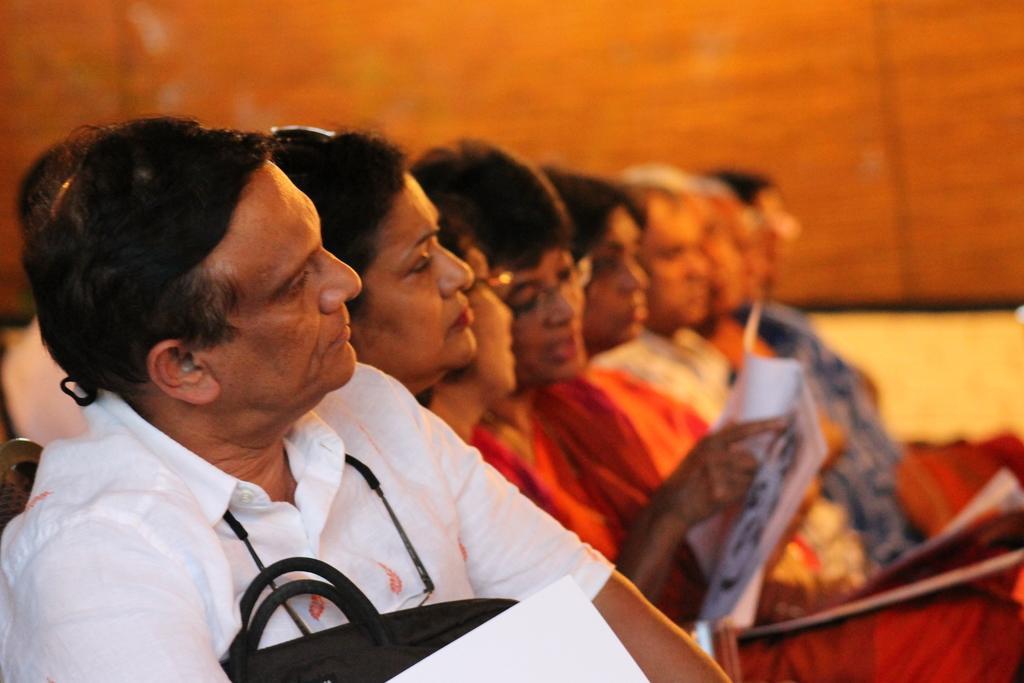Can you describe this image briefly? In the image we can see there are many people sitting in a row, they are wearing clothes, these are the spectacles, papers, book and the background is blurred. 